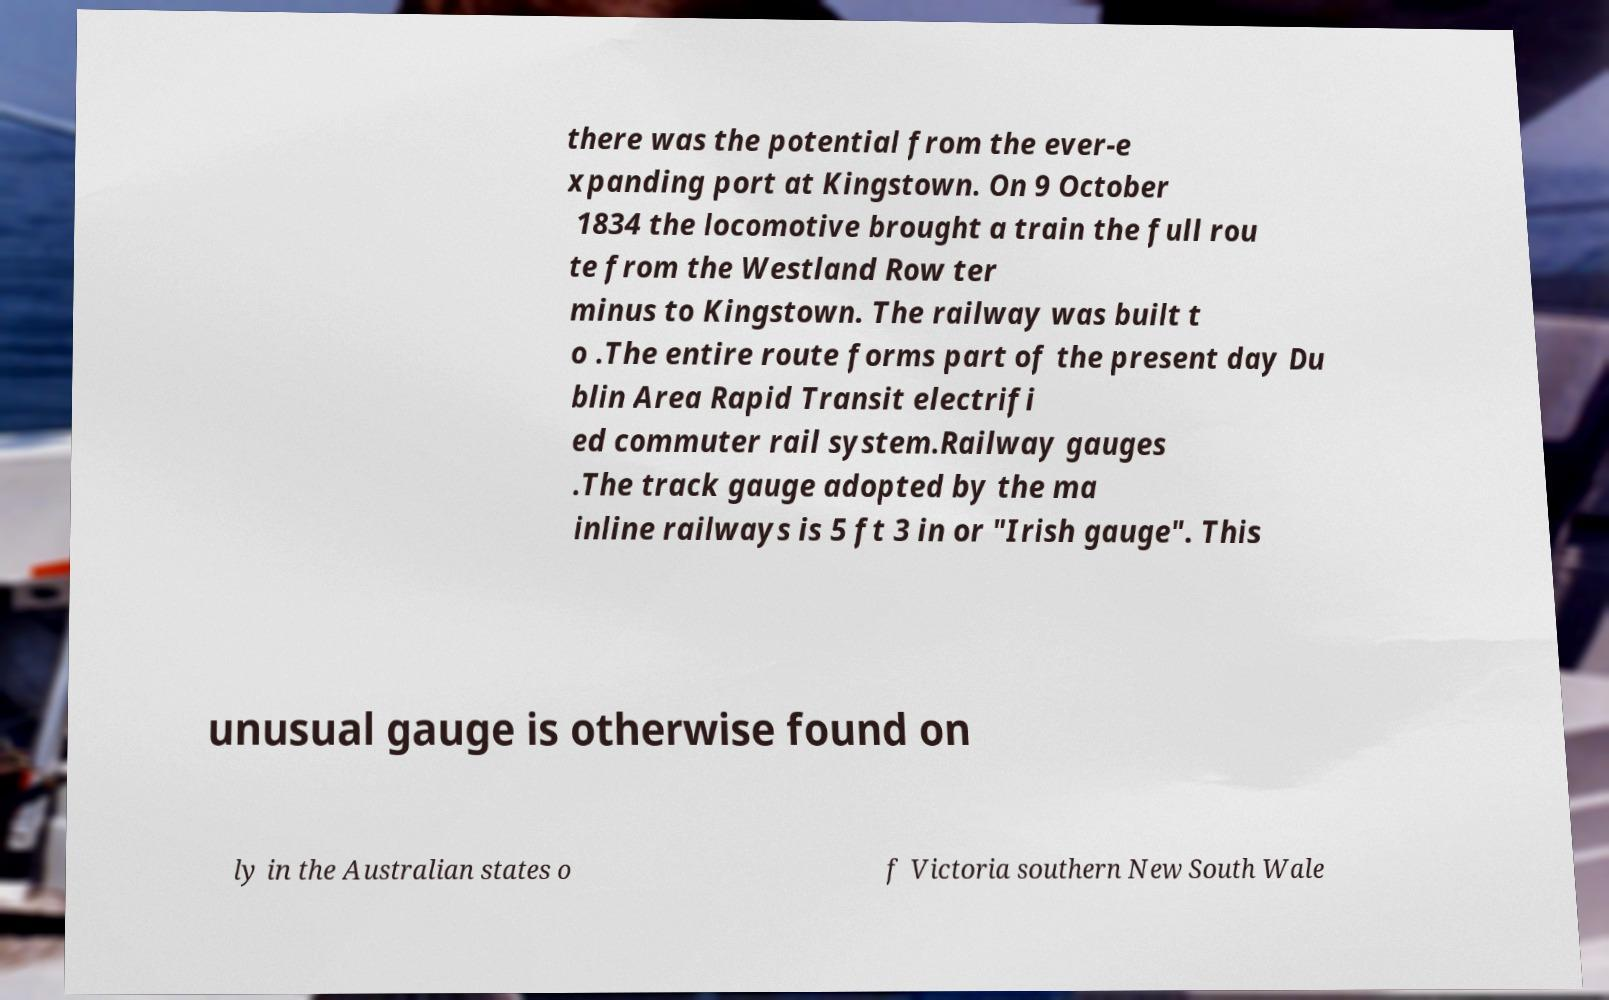There's text embedded in this image that I need extracted. Can you transcribe it verbatim? there was the potential from the ever-e xpanding port at Kingstown. On 9 October 1834 the locomotive brought a train the full rou te from the Westland Row ter minus to Kingstown. The railway was built t o .The entire route forms part of the present day Du blin Area Rapid Transit electrifi ed commuter rail system.Railway gauges .The track gauge adopted by the ma inline railways is 5 ft 3 in or "Irish gauge". This unusual gauge is otherwise found on ly in the Australian states o f Victoria southern New South Wale 